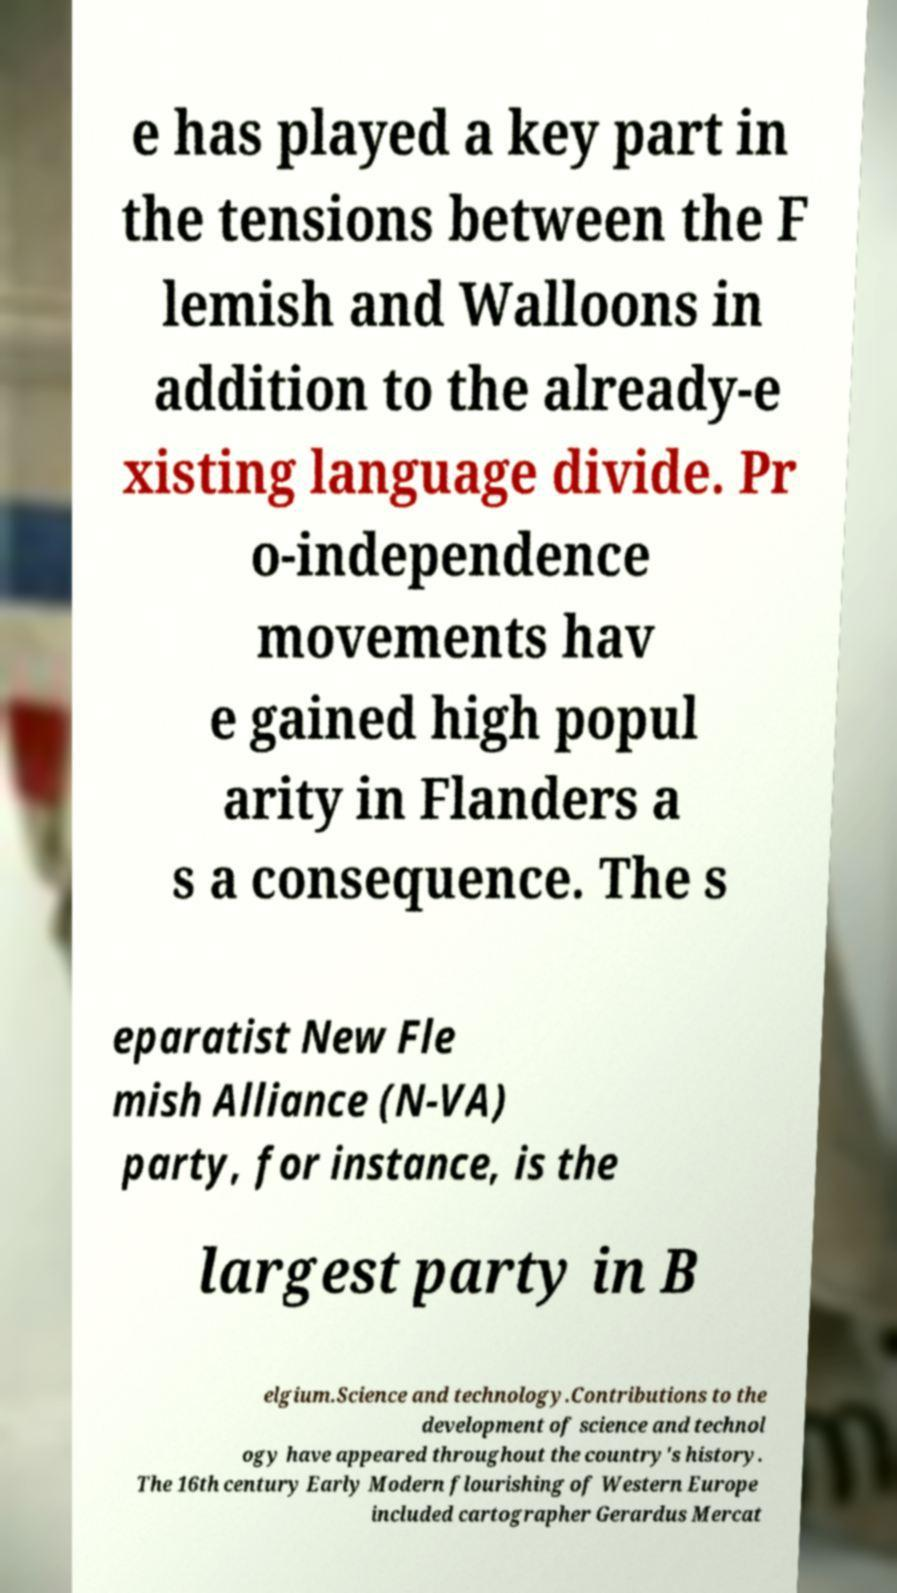For documentation purposes, I need the text within this image transcribed. Could you provide that? e has played a key part in the tensions between the F lemish and Walloons in addition to the already-e xisting language divide. Pr o-independence movements hav e gained high popul arity in Flanders a s a consequence. The s eparatist New Fle mish Alliance (N-VA) party, for instance, is the largest party in B elgium.Science and technology.Contributions to the development of science and technol ogy have appeared throughout the country's history. The 16th century Early Modern flourishing of Western Europe included cartographer Gerardus Mercat 